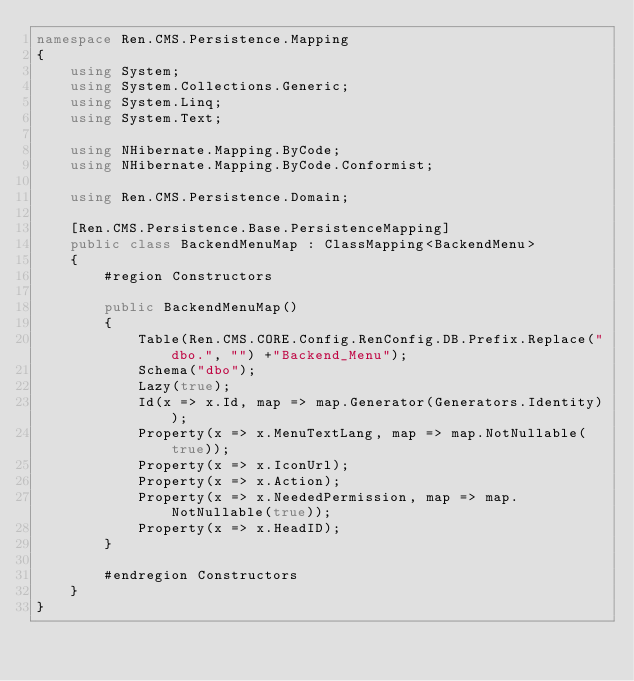Convert code to text. <code><loc_0><loc_0><loc_500><loc_500><_C#_>namespace Ren.CMS.Persistence.Mapping
{
    using System;
    using System.Collections.Generic;
    using System.Linq;
    using System.Text;

    using NHibernate.Mapping.ByCode;
    using NHibernate.Mapping.ByCode.Conformist;

    using Ren.CMS.Persistence.Domain;

    [Ren.CMS.Persistence.Base.PersistenceMapping]
    public class BackendMenuMap : ClassMapping<BackendMenu>
    {
        #region Constructors

        public BackendMenuMap()
        {
            Table(Ren.CMS.CORE.Config.RenConfig.DB.Prefix.Replace("dbo.", "") +"Backend_Menu");
            Schema("dbo");
            Lazy(true);
            Id(x => x.Id, map => map.Generator(Generators.Identity));
            Property(x => x.MenuTextLang, map => map.NotNullable(true));
            Property(x => x.IconUrl);
            Property(x => x.Action);
            Property(x => x.NeededPermission, map => map.NotNullable(true));
            Property(x => x.HeadID);
        }

        #endregion Constructors
    }
}</code> 